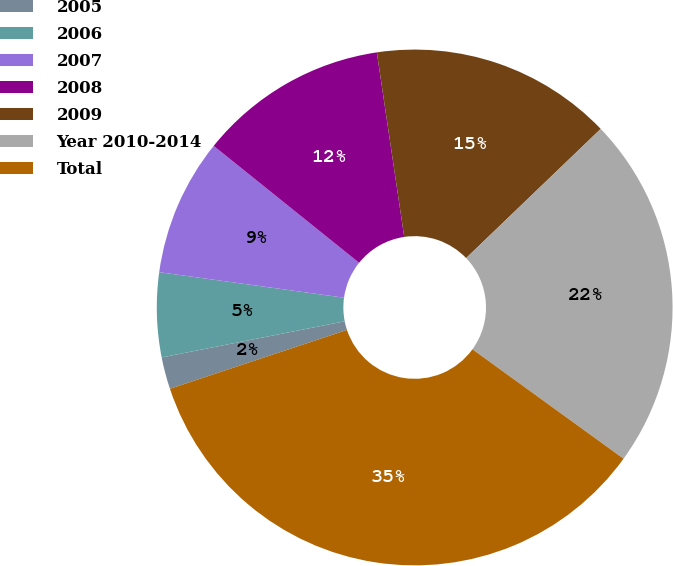Convert chart. <chart><loc_0><loc_0><loc_500><loc_500><pie_chart><fcel>2005<fcel>2006<fcel>2007<fcel>2008<fcel>2009<fcel>Year 2010-2014<fcel>Total<nl><fcel>2.0%<fcel>5.29%<fcel>8.59%<fcel>11.88%<fcel>15.17%<fcel>22.15%<fcel>34.92%<nl></chart> 